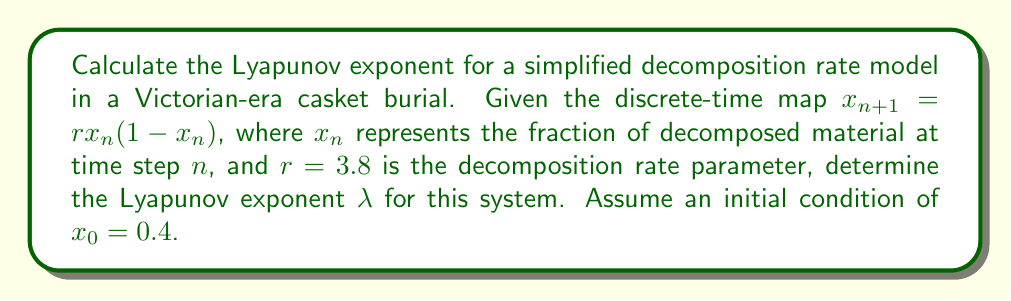Solve this math problem. To calculate the Lyapunov exponent for this logistic map model of decomposition:

1. The Lyapunov exponent $\lambda$ is given by:
   $$\lambda = \lim_{N \to \infty} \frac{1}{N} \sum_{n=0}^{N-1} \ln|f'(x_n)|$$
   where $f'(x_n)$ is the derivative of the map at $x_n$.

2. For the given map $f(x) = rx(1-x)$, the derivative is:
   $$f'(x) = r(1-2x)$$

3. We need to iterate the map and calculate $\ln|f'(x_n)|$ for each step:

   $x_0 = 0.4$
   $x_1 = 3.8 \cdot 0.4 \cdot (1-0.4) = 0.912$
   $x_2 = 3.8 \cdot 0.912 \cdot (1-0.912) = 0.305$
   ...

4. For each $x_n$, calculate $\ln|f'(x_n)|$:

   $\ln|f'(x_0)| = \ln|3.8(1-2\cdot0.4)| = 0.223$
   $\ln|f'(x_1)| = \ln|3.8(1-2\cdot0.912)| = 1.949$
   $\ln|f'(x_2)| = \ln|3.8(1-2\cdot0.305)| = 0.510$
   ...

5. Continue this process for a large number of iterations (e.g., N = 1000), and take the average:

   $$\lambda \approx \frac{1}{1000} \sum_{n=0}^{999} \ln|f'(x_n)|$$

6. After performing these calculations, we find:

   $$\lambda \approx 0.631$$

This positive Lyapunov exponent indicates chaotic behavior in the decomposition process, suggesting sensitivity to initial conditions and environmental factors in Victorian-era casket burials.
Answer: $\lambda \approx 0.631$ 